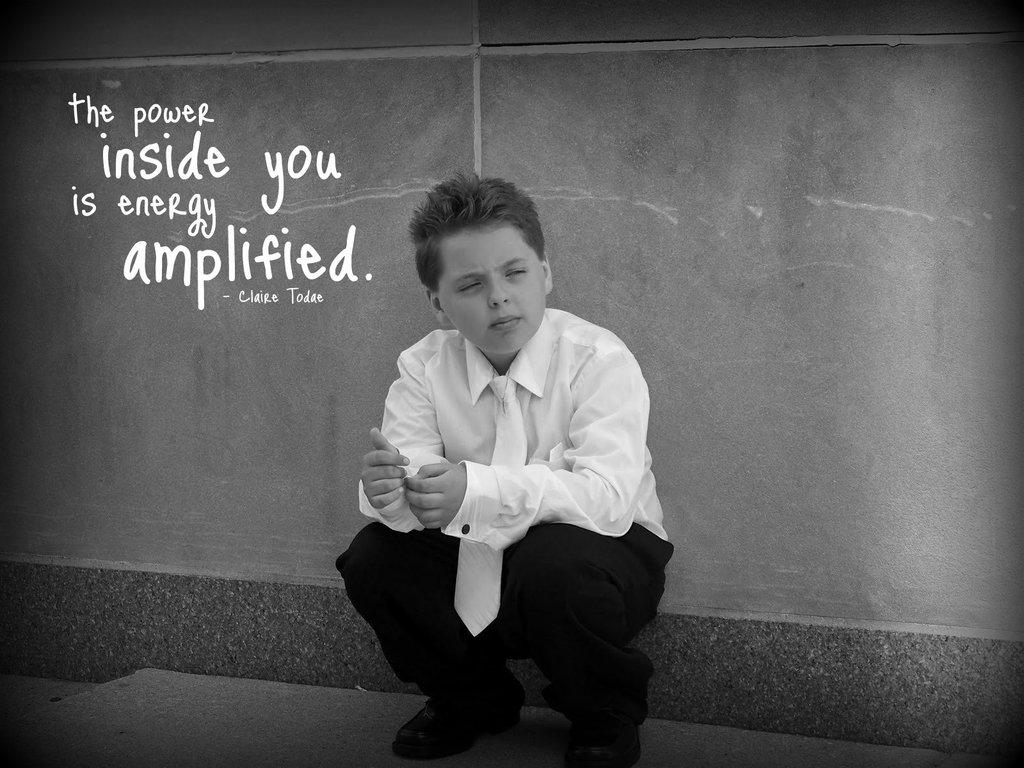What is the main subject of the image? The main subject of the image is a kid sitting. Can you describe anything in the top left corner of the image? Yes, there is text or an image in the left top corner of the image. How many sheets of paper are visible in the image? There is no mention of sheets of paper in the provided facts, so it cannot be determined from the image. 